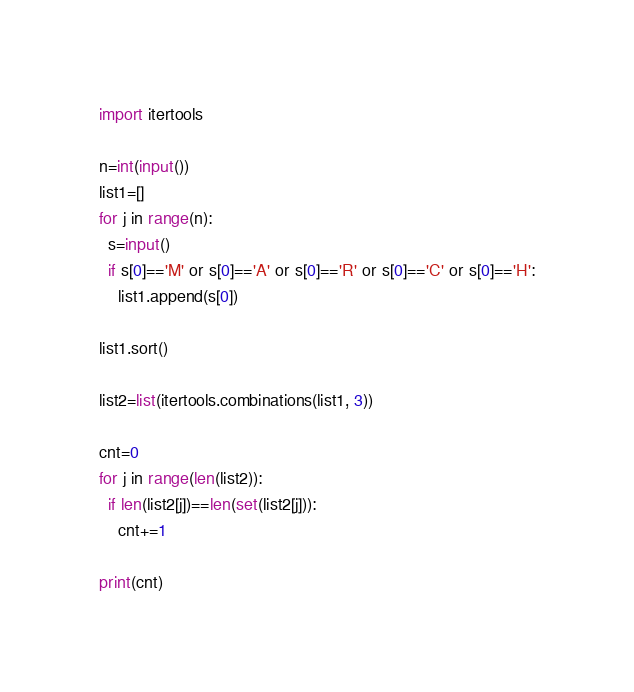Convert code to text. <code><loc_0><loc_0><loc_500><loc_500><_Python_>import itertools

n=int(input())
list1=[]
for j in range(n):
  s=input()
  if s[0]=='M' or s[0]=='A' or s[0]=='R' or s[0]=='C' or s[0]=='H':
    list1.append(s[0])

list1.sort()

list2=list(itertools.combinations(list1, 3))

cnt=0
for j in range(len(list2)):
  if len(list2[j])==len(set(list2[j])):
    cnt+=1

print(cnt)
</code> 